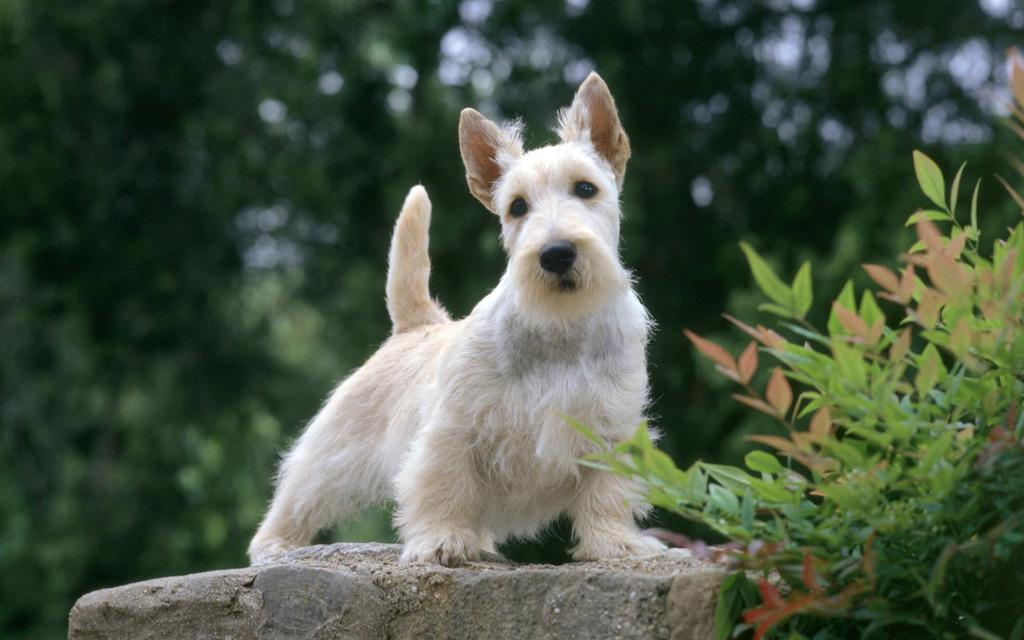What type of animal is in the image? There is a white color dog in the image. Where is the dog positioned in the image? The dog is standing on the rocks. What can be seen in the background of the image? There are plants and trees in the background of the image. How is the background of the image depicted? The background of the image is blurred. What is the dog writing on the rocks in the image? The dog is not writing anything in the image; it is simply standing on the rocks. 